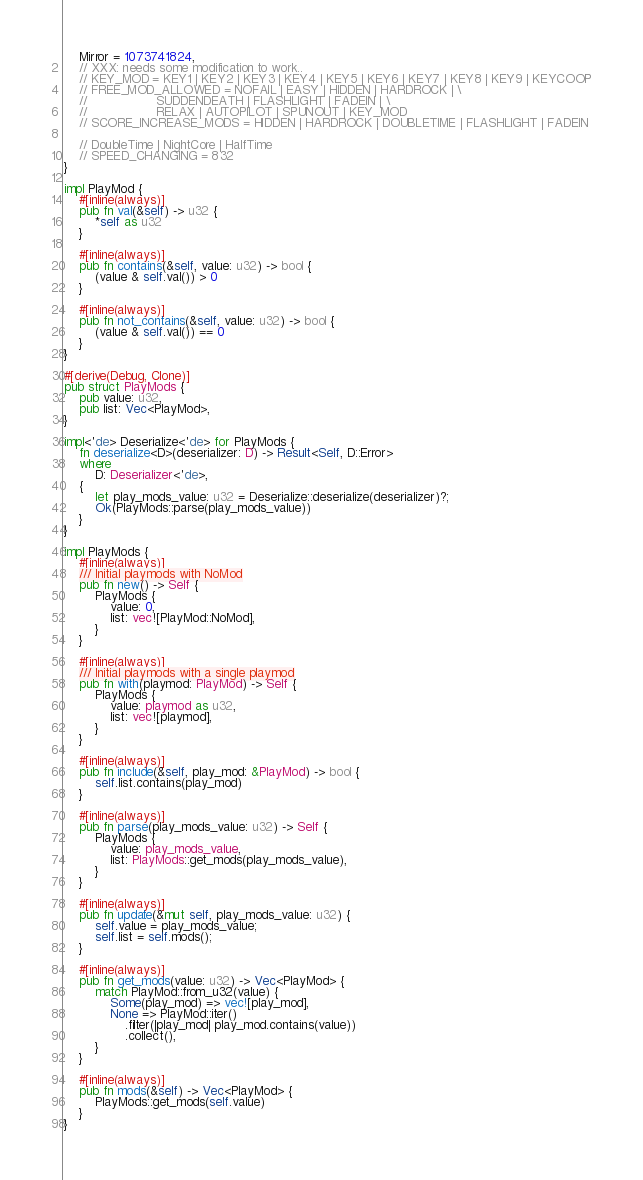<code> <loc_0><loc_0><loc_500><loc_500><_Rust_>    Mirror = 1073741824,
    // XXX: needs some modification to work..
    // KEY_MOD = KEY1 | KEY2 | KEY3 | KEY4 | KEY5 | KEY6 | KEY7 | KEY8 | KEY9 | KEYCOOP
    // FREE_MOD_ALLOWED = NOFAIL | EASY | HIDDEN | HARDROCK | \
    //                  SUDDENDEATH | FLASHLIGHT | FADEIN | \
    //                  RELAX | AUTOPILOT | SPUNOUT | KEY_MOD
    // SCORE_INCREASE_MODS = HIDDEN | HARDROCK | DOUBLETIME | FLASHLIGHT | FADEIN

    // DoubleTime | NightCore | HalfTime
    // SPEED_CHANGING = 832
}

impl PlayMod {
    #[inline(always)]
    pub fn val(&self) -> u32 {
        *self as u32
    }

    #[inline(always)]
    pub fn contains(&self, value: u32) -> bool {
        (value & self.val()) > 0
    }

    #[inline(always)]
    pub fn not_contains(&self, value: u32) -> bool {
        (value & self.val()) == 0
    }
}

#[derive(Debug, Clone)]
pub struct PlayMods {
    pub value: u32,
    pub list: Vec<PlayMod>,
}

impl<'de> Deserialize<'de> for PlayMods {
    fn deserialize<D>(deserializer: D) -> Result<Self, D::Error>
    where
        D: Deserializer<'de>,
    {
        let play_mods_value: u32 = Deserialize::deserialize(deserializer)?;
        Ok(PlayMods::parse(play_mods_value))
    }
}

impl PlayMods {
    #[inline(always)]
    /// Initial playmods with NoMod
    pub fn new() -> Self {
        PlayMods {
            value: 0,
            list: vec![PlayMod::NoMod],
        }
    }

    #[inline(always)]
    /// Initial playmods with a single playmod
    pub fn with(playmod: PlayMod) -> Self {
        PlayMods {
            value: playmod as u32,
            list: vec![playmod],
        }
    }

    #[inline(always)]
    pub fn include(&self, play_mod: &PlayMod) -> bool {
        self.list.contains(play_mod)
    }

    #[inline(always)]
    pub fn parse(play_mods_value: u32) -> Self {
        PlayMods {
            value: play_mods_value,
            list: PlayMods::get_mods(play_mods_value),
        }
    }

    #[inline(always)]
    pub fn update(&mut self, play_mods_value: u32) {
        self.value = play_mods_value;
        self.list = self.mods();
    }

    #[inline(always)]
    pub fn get_mods(value: u32) -> Vec<PlayMod> {
        match PlayMod::from_u32(value) {
            Some(play_mod) => vec![play_mod],
            None => PlayMod::iter()
                .filter(|play_mod| play_mod.contains(value))
                .collect(),
        }
    }

    #[inline(always)]
    pub fn mods(&self) -> Vec<PlayMod> {
        PlayMods::get_mods(self.value)
    }
}
</code> 